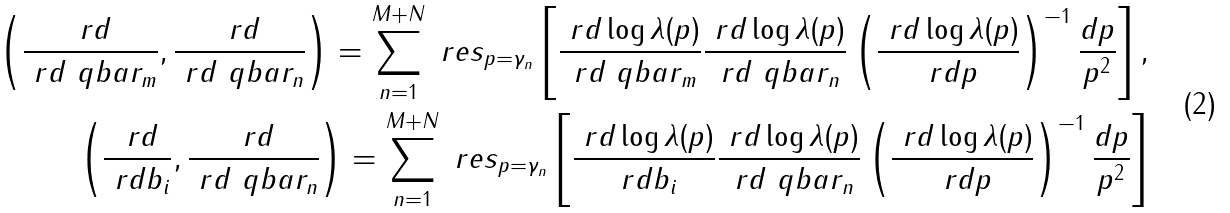<formula> <loc_0><loc_0><loc_500><loc_500>\left ( \frac { \ r d } { \ r d \ q b a r _ { m } } , \frac { \ r d } { \ r d \ q b a r _ { n } } \right ) = \sum _ { n = 1 } ^ { M + N } \ r e s _ { p = \gamma _ { n } } \left [ \frac { \ r d \log \lambda ( p ) } { \ r d \ q b a r _ { m } } \frac { \ r d \log \lambda ( p ) } { \ r d \ q b a r _ { n } } \left ( \frac { \ r d \log \lambda ( p ) } { \ r d p } \right ) ^ { - 1 } \frac { d p } { p ^ { 2 } } \right ] , \\ \left ( \frac { \ r d } { \ r d b _ { i } } , \frac { \ r d } { \ r d \ q b a r _ { n } } \right ) = \sum _ { n = 1 } ^ { M + N } \ r e s _ { p = \gamma _ { n } } \left [ \frac { \ r d \log \lambda ( p ) } { \ r d b _ { i } } \frac { \ r d \log \lambda ( p ) } { \ r d \ q b a r _ { n } } \left ( \frac { \ r d \log \lambda ( p ) } { \ r d p } \right ) ^ { - 1 } \frac { d p } { p ^ { 2 } } \right ]</formula> 